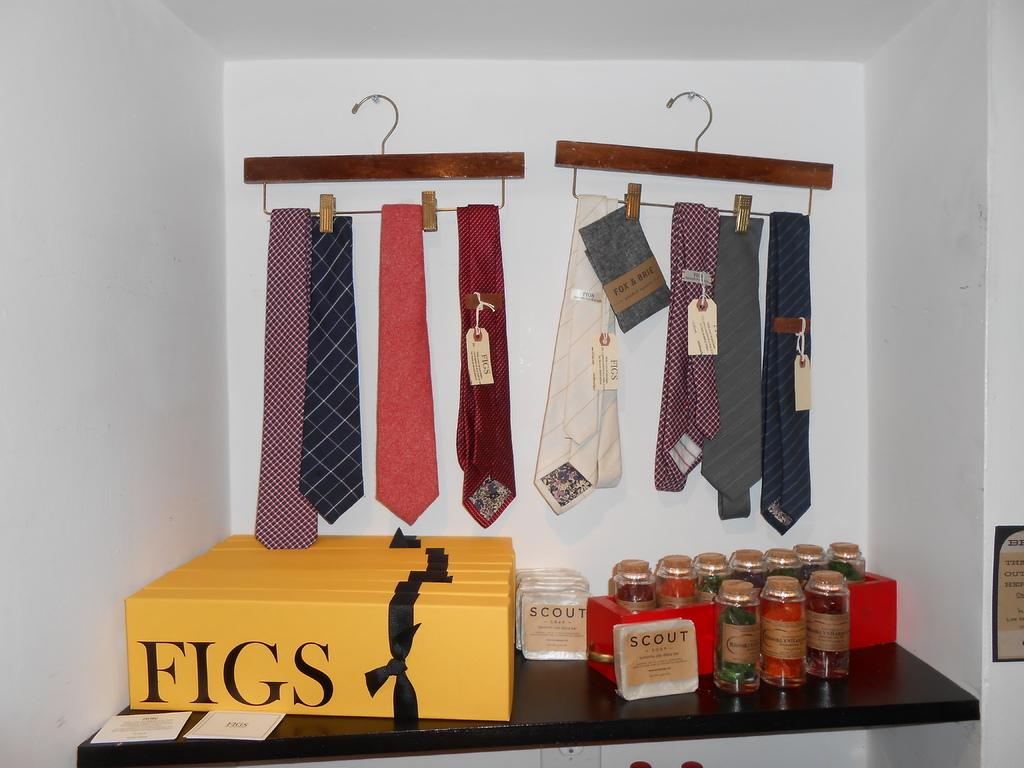<image>
Share a concise interpretation of the image provided. a yellow chocolate box wit the word figs on it 